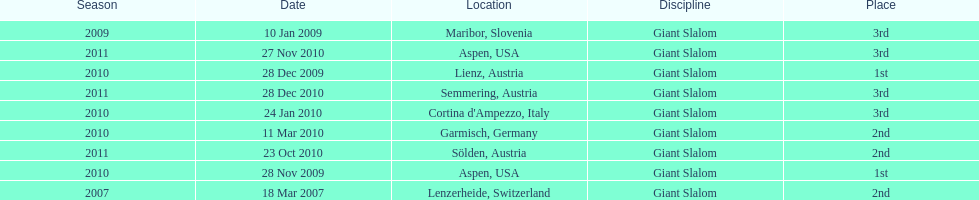How many races were in 2010? 5. 